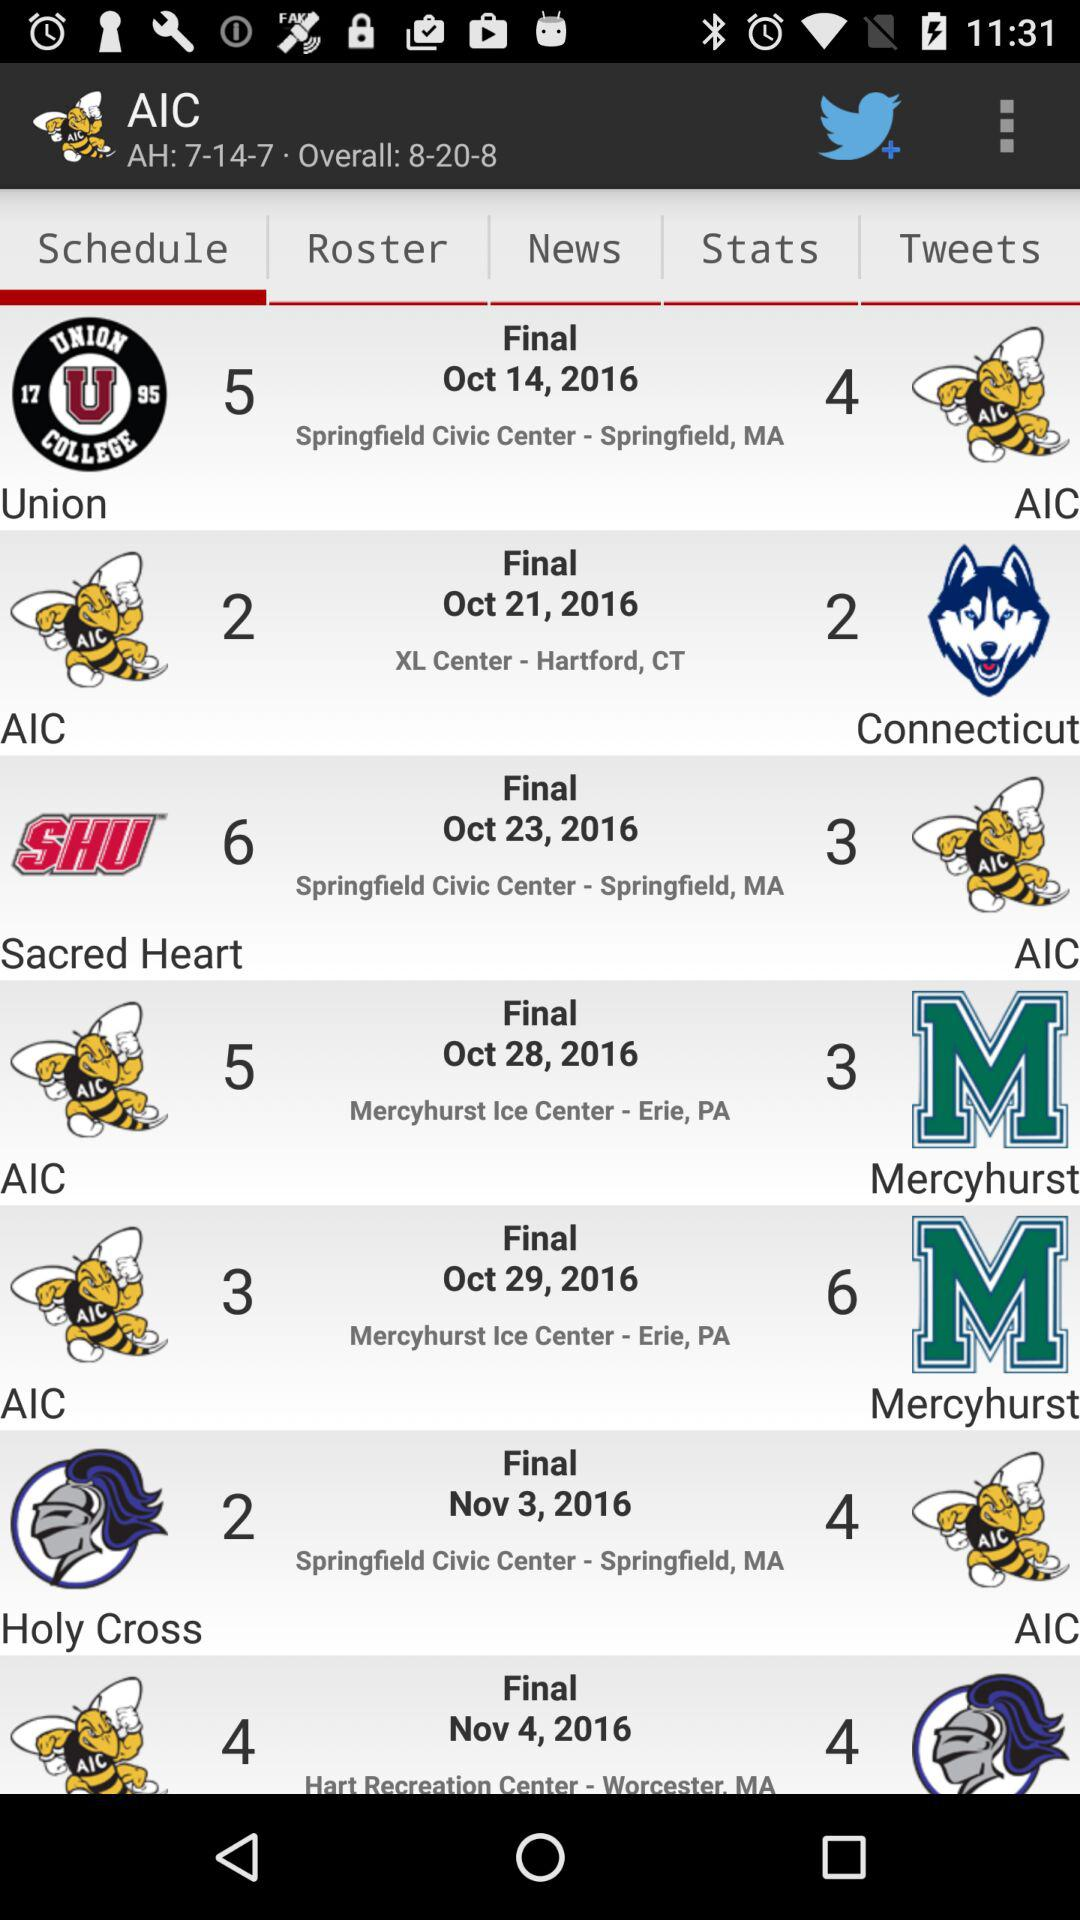What's the "AH"? The "AH" is "7-14-7". 